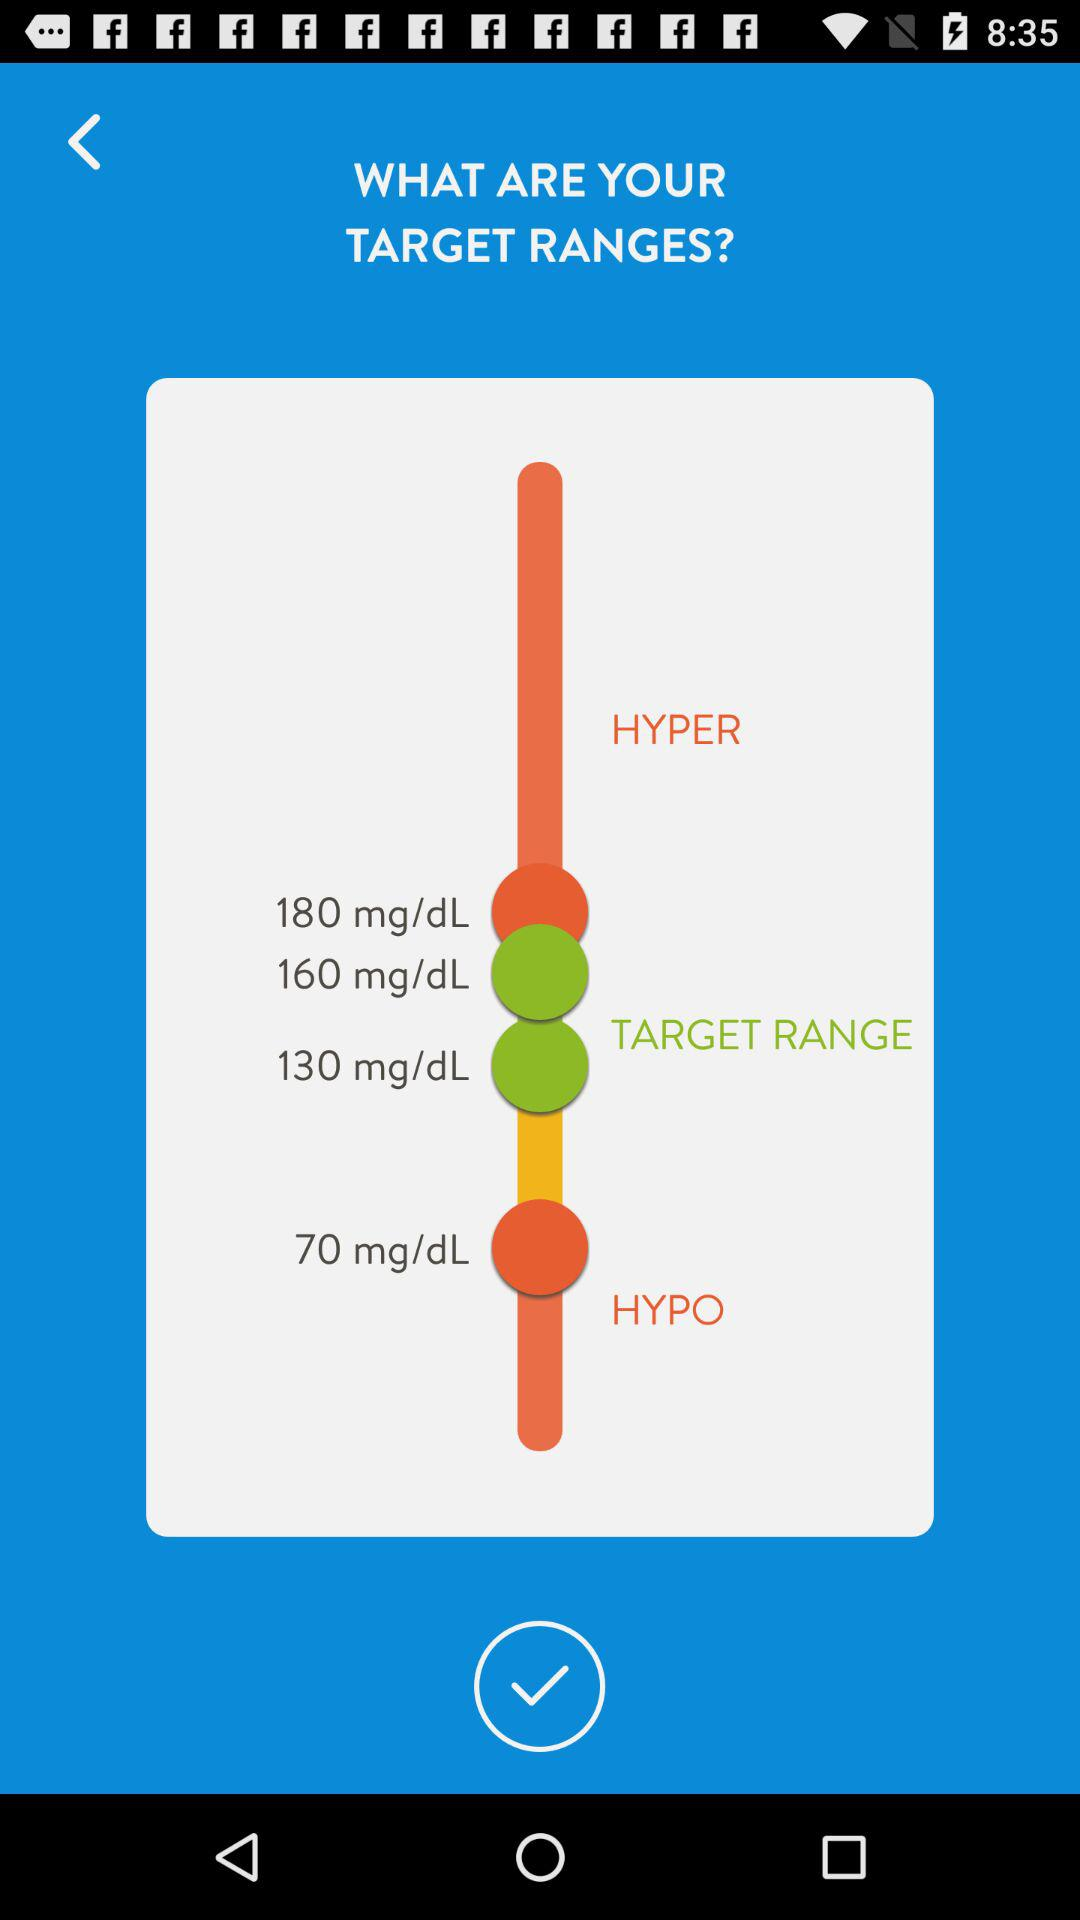What is the difference in mg/dL between the lowest and highest target ranges?
Answer the question using a single word or phrase. 110 